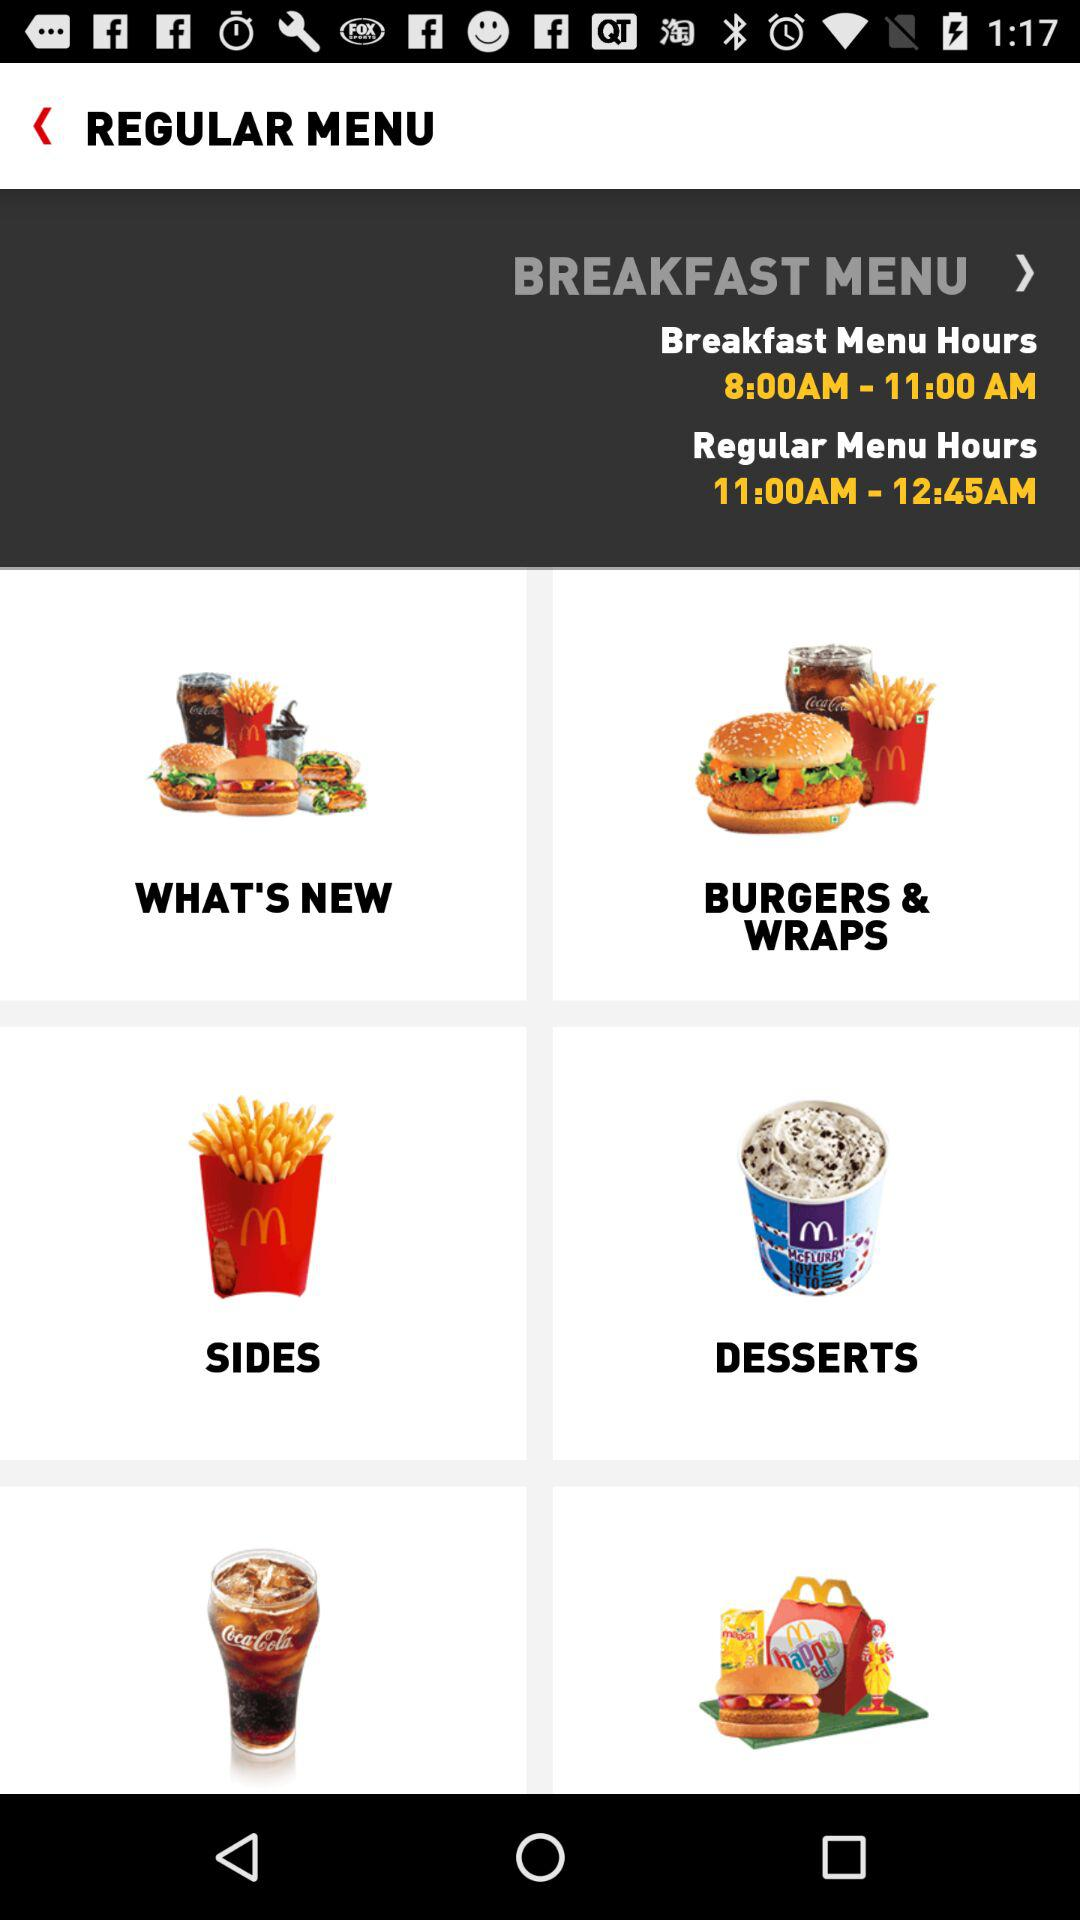What are the timings given for the regular menu hours? The timings given for the regular menu hours are 11:00AM–12:45AM. 